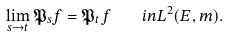<formula> <loc_0><loc_0><loc_500><loc_500>\lim _ { s \to t } \mathfrak { P } _ { s } f = \mathfrak { P } _ { t } f \quad i n L ^ { 2 } ( E , m ) .</formula> 